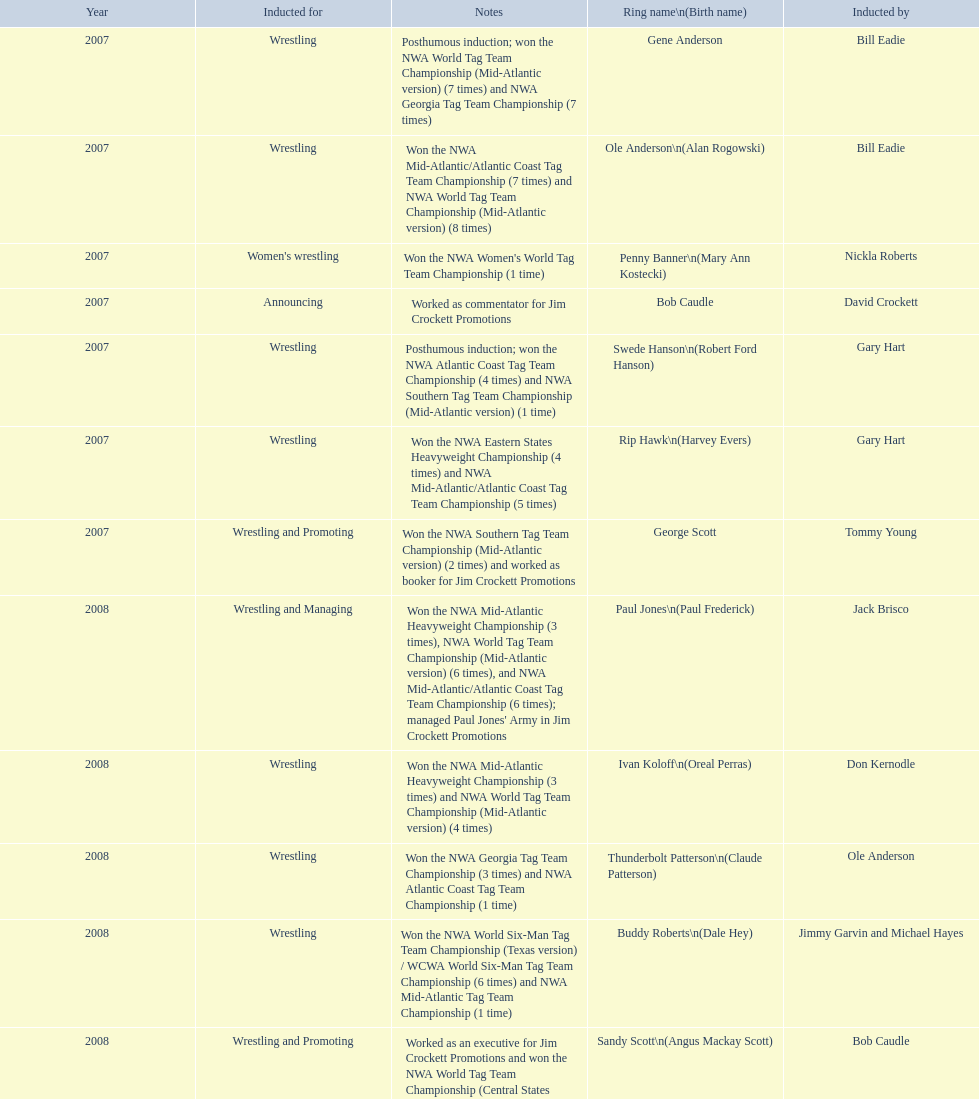Bob caudle was an announcer, who was the other one? Lance Russell. 